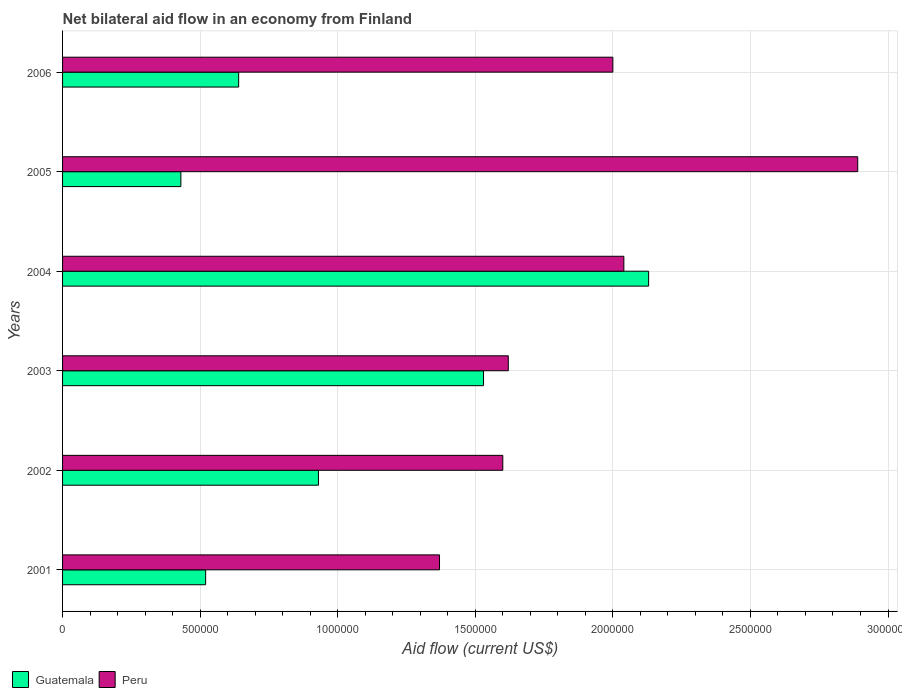Are the number of bars on each tick of the Y-axis equal?
Offer a terse response. Yes. What is the label of the 3rd group of bars from the top?
Your response must be concise. 2004. What is the net bilateral aid flow in Guatemala in 2006?
Offer a very short reply. 6.40e+05. Across all years, what is the maximum net bilateral aid flow in Guatemala?
Your response must be concise. 2.13e+06. In which year was the net bilateral aid flow in Peru minimum?
Keep it short and to the point. 2001. What is the total net bilateral aid flow in Peru in the graph?
Provide a short and direct response. 1.15e+07. What is the difference between the net bilateral aid flow in Peru in 2002 and that in 2003?
Provide a succinct answer. -2.00e+04. What is the difference between the net bilateral aid flow in Guatemala in 2006 and the net bilateral aid flow in Peru in 2002?
Ensure brevity in your answer.  -9.60e+05. What is the average net bilateral aid flow in Peru per year?
Your answer should be very brief. 1.92e+06. In the year 2006, what is the difference between the net bilateral aid flow in Guatemala and net bilateral aid flow in Peru?
Give a very brief answer. -1.36e+06. What is the ratio of the net bilateral aid flow in Guatemala in 2001 to that in 2004?
Make the answer very short. 0.24. Is the net bilateral aid flow in Guatemala in 2005 less than that in 2006?
Your response must be concise. Yes. What is the difference between the highest and the second highest net bilateral aid flow in Guatemala?
Give a very brief answer. 6.00e+05. What is the difference between the highest and the lowest net bilateral aid flow in Peru?
Offer a very short reply. 1.52e+06. In how many years, is the net bilateral aid flow in Guatemala greater than the average net bilateral aid flow in Guatemala taken over all years?
Give a very brief answer. 2. Is the sum of the net bilateral aid flow in Peru in 2002 and 2004 greater than the maximum net bilateral aid flow in Guatemala across all years?
Give a very brief answer. Yes. What does the 1st bar from the top in 2001 represents?
Give a very brief answer. Peru. What does the 1st bar from the bottom in 2006 represents?
Make the answer very short. Guatemala. Are all the bars in the graph horizontal?
Provide a short and direct response. Yes. What is the difference between two consecutive major ticks on the X-axis?
Your answer should be very brief. 5.00e+05. Does the graph contain grids?
Offer a very short reply. Yes. Where does the legend appear in the graph?
Your answer should be very brief. Bottom left. How are the legend labels stacked?
Provide a succinct answer. Horizontal. What is the title of the graph?
Your answer should be compact. Net bilateral aid flow in an economy from Finland. What is the label or title of the X-axis?
Offer a very short reply. Aid flow (current US$). What is the label or title of the Y-axis?
Keep it short and to the point. Years. What is the Aid flow (current US$) in Guatemala in 2001?
Ensure brevity in your answer.  5.20e+05. What is the Aid flow (current US$) of Peru in 2001?
Offer a very short reply. 1.37e+06. What is the Aid flow (current US$) of Guatemala in 2002?
Your response must be concise. 9.30e+05. What is the Aid flow (current US$) in Peru in 2002?
Your answer should be compact. 1.60e+06. What is the Aid flow (current US$) of Guatemala in 2003?
Provide a succinct answer. 1.53e+06. What is the Aid flow (current US$) in Peru in 2003?
Make the answer very short. 1.62e+06. What is the Aid flow (current US$) of Guatemala in 2004?
Make the answer very short. 2.13e+06. What is the Aid flow (current US$) in Peru in 2004?
Provide a short and direct response. 2.04e+06. What is the Aid flow (current US$) of Peru in 2005?
Provide a short and direct response. 2.89e+06. What is the Aid flow (current US$) of Guatemala in 2006?
Give a very brief answer. 6.40e+05. Across all years, what is the maximum Aid flow (current US$) of Guatemala?
Offer a very short reply. 2.13e+06. Across all years, what is the maximum Aid flow (current US$) in Peru?
Your response must be concise. 2.89e+06. Across all years, what is the minimum Aid flow (current US$) in Guatemala?
Ensure brevity in your answer.  4.30e+05. Across all years, what is the minimum Aid flow (current US$) in Peru?
Keep it short and to the point. 1.37e+06. What is the total Aid flow (current US$) in Guatemala in the graph?
Provide a succinct answer. 6.18e+06. What is the total Aid flow (current US$) of Peru in the graph?
Your answer should be compact. 1.15e+07. What is the difference between the Aid flow (current US$) of Guatemala in 2001 and that in 2002?
Your response must be concise. -4.10e+05. What is the difference between the Aid flow (current US$) of Guatemala in 2001 and that in 2003?
Provide a short and direct response. -1.01e+06. What is the difference between the Aid flow (current US$) of Guatemala in 2001 and that in 2004?
Provide a short and direct response. -1.61e+06. What is the difference between the Aid flow (current US$) in Peru in 2001 and that in 2004?
Provide a short and direct response. -6.70e+05. What is the difference between the Aid flow (current US$) of Peru in 2001 and that in 2005?
Your answer should be compact. -1.52e+06. What is the difference between the Aid flow (current US$) of Guatemala in 2001 and that in 2006?
Offer a terse response. -1.20e+05. What is the difference between the Aid flow (current US$) in Peru in 2001 and that in 2006?
Give a very brief answer. -6.30e+05. What is the difference between the Aid flow (current US$) in Guatemala in 2002 and that in 2003?
Offer a terse response. -6.00e+05. What is the difference between the Aid flow (current US$) of Guatemala in 2002 and that in 2004?
Your answer should be very brief. -1.20e+06. What is the difference between the Aid flow (current US$) in Peru in 2002 and that in 2004?
Ensure brevity in your answer.  -4.40e+05. What is the difference between the Aid flow (current US$) in Guatemala in 2002 and that in 2005?
Your response must be concise. 5.00e+05. What is the difference between the Aid flow (current US$) of Peru in 2002 and that in 2005?
Give a very brief answer. -1.29e+06. What is the difference between the Aid flow (current US$) in Guatemala in 2002 and that in 2006?
Give a very brief answer. 2.90e+05. What is the difference between the Aid flow (current US$) of Peru in 2002 and that in 2006?
Your answer should be compact. -4.00e+05. What is the difference between the Aid flow (current US$) of Guatemala in 2003 and that in 2004?
Offer a very short reply. -6.00e+05. What is the difference between the Aid flow (current US$) in Peru in 2003 and that in 2004?
Offer a terse response. -4.20e+05. What is the difference between the Aid flow (current US$) of Guatemala in 2003 and that in 2005?
Provide a short and direct response. 1.10e+06. What is the difference between the Aid flow (current US$) in Peru in 2003 and that in 2005?
Offer a very short reply. -1.27e+06. What is the difference between the Aid flow (current US$) in Guatemala in 2003 and that in 2006?
Offer a terse response. 8.90e+05. What is the difference between the Aid flow (current US$) of Peru in 2003 and that in 2006?
Your answer should be very brief. -3.80e+05. What is the difference between the Aid flow (current US$) of Guatemala in 2004 and that in 2005?
Provide a succinct answer. 1.70e+06. What is the difference between the Aid flow (current US$) of Peru in 2004 and that in 2005?
Your response must be concise. -8.50e+05. What is the difference between the Aid flow (current US$) of Guatemala in 2004 and that in 2006?
Provide a short and direct response. 1.49e+06. What is the difference between the Aid flow (current US$) of Peru in 2005 and that in 2006?
Give a very brief answer. 8.90e+05. What is the difference between the Aid flow (current US$) in Guatemala in 2001 and the Aid flow (current US$) in Peru in 2002?
Ensure brevity in your answer.  -1.08e+06. What is the difference between the Aid flow (current US$) of Guatemala in 2001 and the Aid flow (current US$) of Peru in 2003?
Make the answer very short. -1.10e+06. What is the difference between the Aid flow (current US$) of Guatemala in 2001 and the Aid flow (current US$) of Peru in 2004?
Provide a short and direct response. -1.52e+06. What is the difference between the Aid flow (current US$) of Guatemala in 2001 and the Aid flow (current US$) of Peru in 2005?
Your answer should be very brief. -2.37e+06. What is the difference between the Aid flow (current US$) in Guatemala in 2001 and the Aid flow (current US$) in Peru in 2006?
Offer a terse response. -1.48e+06. What is the difference between the Aid flow (current US$) of Guatemala in 2002 and the Aid flow (current US$) of Peru in 2003?
Offer a very short reply. -6.90e+05. What is the difference between the Aid flow (current US$) in Guatemala in 2002 and the Aid flow (current US$) in Peru in 2004?
Give a very brief answer. -1.11e+06. What is the difference between the Aid flow (current US$) of Guatemala in 2002 and the Aid flow (current US$) of Peru in 2005?
Your answer should be very brief. -1.96e+06. What is the difference between the Aid flow (current US$) of Guatemala in 2002 and the Aid flow (current US$) of Peru in 2006?
Offer a very short reply. -1.07e+06. What is the difference between the Aid flow (current US$) in Guatemala in 2003 and the Aid flow (current US$) in Peru in 2004?
Your answer should be compact. -5.10e+05. What is the difference between the Aid flow (current US$) in Guatemala in 2003 and the Aid flow (current US$) in Peru in 2005?
Give a very brief answer. -1.36e+06. What is the difference between the Aid flow (current US$) of Guatemala in 2003 and the Aid flow (current US$) of Peru in 2006?
Ensure brevity in your answer.  -4.70e+05. What is the difference between the Aid flow (current US$) of Guatemala in 2004 and the Aid flow (current US$) of Peru in 2005?
Offer a very short reply. -7.60e+05. What is the difference between the Aid flow (current US$) of Guatemala in 2004 and the Aid flow (current US$) of Peru in 2006?
Provide a short and direct response. 1.30e+05. What is the difference between the Aid flow (current US$) of Guatemala in 2005 and the Aid flow (current US$) of Peru in 2006?
Your response must be concise. -1.57e+06. What is the average Aid flow (current US$) in Guatemala per year?
Your answer should be very brief. 1.03e+06. What is the average Aid flow (current US$) in Peru per year?
Your answer should be very brief. 1.92e+06. In the year 2001, what is the difference between the Aid flow (current US$) in Guatemala and Aid flow (current US$) in Peru?
Provide a succinct answer. -8.50e+05. In the year 2002, what is the difference between the Aid flow (current US$) in Guatemala and Aid flow (current US$) in Peru?
Make the answer very short. -6.70e+05. In the year 2003, what is the difference between the Aid flow (current US$) of Guatemala and Aid flow (current US$) of Peru?
Give a very brief answer. -9.00e+04. In the year 2005, what is the difference between the Aid flow (current US$) of Guatemala and Aid flow (current US$) of Peru?
Your response must be concise. -2.46e+06. In the year 2006, what is the difference between the Aid flow (current US$) of Guatemala and Aid flow (current US$) of Peru?
Ensure brevity in your answer.  -1.36e+06. What is the ratio of the Aid flow (current US$) of Guatemala in 2001 to that in 2002?
Provide a short and direct response. 0.56. What is the ratio of the Aid flow (current US$) in Peru in 2001 to that in 2002?
Keep it short and to the point. 0.86. What is the ratio of the Aid flow (current US$) in Guatemala in 2001 to that in 2003?
Provide a short and direct response. 0.34. What is the ratio of the Aid flow (current US$) of Peru in 2001 to that in 2003?
Provide a short and direct response. 0.85. What is the ratio of the Aid flow (current US$) in Guatemala in 2001 to that in 2004?
Ensure brevity in your answer.  0.24. What is the ratio of the Aid flow (current US$) of Peru in 2001 to that in 2004?
Provide a short and direct response. 0.67. What is the ratio of the Aid flow (current US$) in Guatemala in 2001 to that in 2005?
Make the answer very short. 1.21. What is the ratio of the Aid flow (current US$) of Peru in 2001 to that in 2005?
Keep it short and to the point. 0.47. What is the ratio of the Aid flow (current US$) of Guatemala in 2001 to that in 2006?
Make the answer very short. 0.81. What is the ratio of the Aid flow (current US$) of Peru in 2001 to that in 2006?
Make the answer very short. 0.69. What is the ratio of the Aid flow (current US$) in Guatemala in 2002 to that in 2003?
Offer a very short reply. 0.61. What is the ratio of the Aid flow (current US$) in Guatemala in 2002 to that in 2004?
Offer a very short reply. 0.44. What is the ratio of the Aid flow (current US$) in Peru in 2002 to that in 2004?
Provide a succinct answer. 0.78. What is the ratio of the Aid flow (current US$) in Guatemala in 2002 to that in 2005?
Ensure brevity in your answer.  2.16. What is the ratio of the Aid flow (current US$) of Peru in 2002 to that in 2005?
Provide a succinct answer. 0.55. What is the ratio of the Aid flow (current US$) in Guatemala in 2002 to that in 2006?
Offer a terse response. 1.45. What is the ratio of the Aid flow (current US$) in Peru in 2002 to that in 2006?
Your answer should be very brief. 0.8. What is the ratio of the Aid flow (current US$) in Guatemala in 2003 to that in 2004?
Provide a succinct answer. 0.72. What is the ratio of the Aid flow (current US$) in Peru in 2003 to that in 2004?
Your answer should be compact. 0.79. What is the ratio of the Aid flow (current US$) of Guatemala in 2003 to that in 2005?
Your answer should be compact. 3.56. What is the ratio of the Aid flow (current US$) of Peru in 2003 to that in 2005?
Provide a succinct answer. 0.56. What is the ratio of the Aid flow (current US$) in Guatemala in 2003 to that in 2006?
Your answer should be compact. 2.39. What is the ratio of the Aid flow (current US$) in Peru in 2003 to that in 2006?
Make the answer very short. 0.81. What is the ratio of the Aid flow (current US$) of Guatemala in 2004 to that in 2005?
Provide a succinct answer. 4.95. What is the ratio of the Aid flow (current US$) in Peru in 2004 to that in 2005?
Your response must be concise. 0.71. What is the ratio of the Aid flow (current US$) in Guatemala in 2004 to that in 2006?
Provide a short and direct response. 3.33. What is the ratio of the Aid flow (current US$) in Guatemala in 2005 to that in 2006?
Keep it short and to the point. 0.67. What is the ratio of the Aid flow (current US$) of Peru in 2005 to that in 2006?
Ensure brevity in your answer.  1.45. What is the difference between the highest and the second highest Aid flow (current US$) in Peru?
Offer a very short reply. 8.50e+05. What is the difference between the highest and the lowest Aid flow (current US$) of Guatemala?
Provide a succinct answer. 1.70e+06. What is the difference between the highest and the lowest Aid flow (current US$) of Peru?
Your answer should be compact. 1.52e+06. 